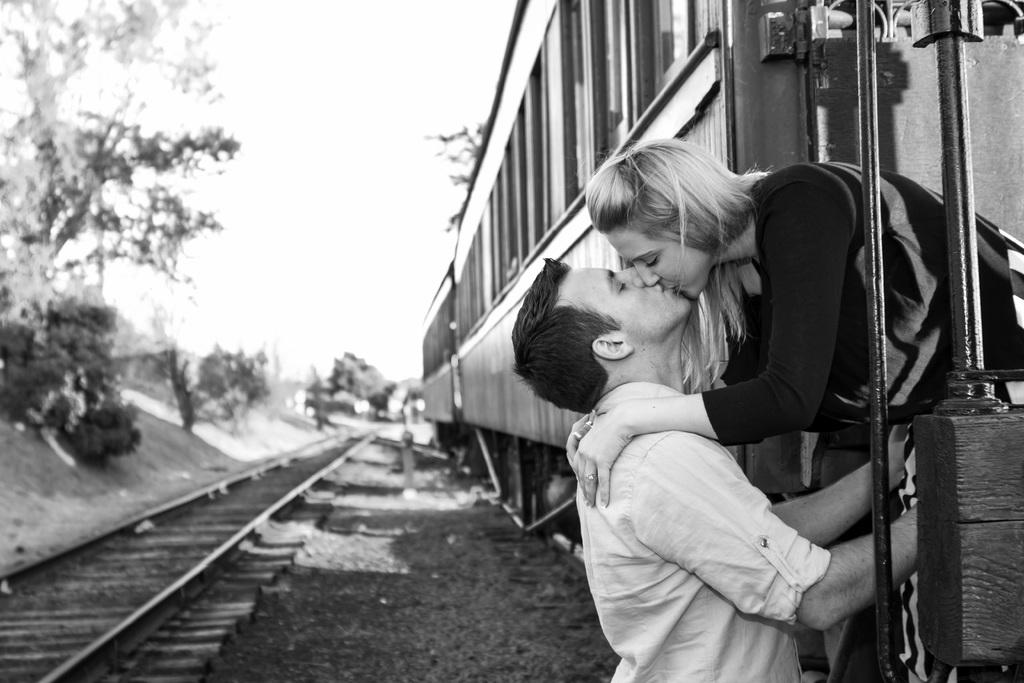Who are the two people in the image? There is a girl and a boy in the image. Where are the girl and boy located in the image? The girl and boy are on the right side of the image. What are the girl and boy doing in the image? The girl and boy are kissing. What can be seen on the opposite side of the image? There are trees on the left side of the image. Can you see a stream in the image? No, there is no stream present in the image. What type of net is being used by the girl and boy in the image? There is no net visible in the image; the girl and boy are kissing. 